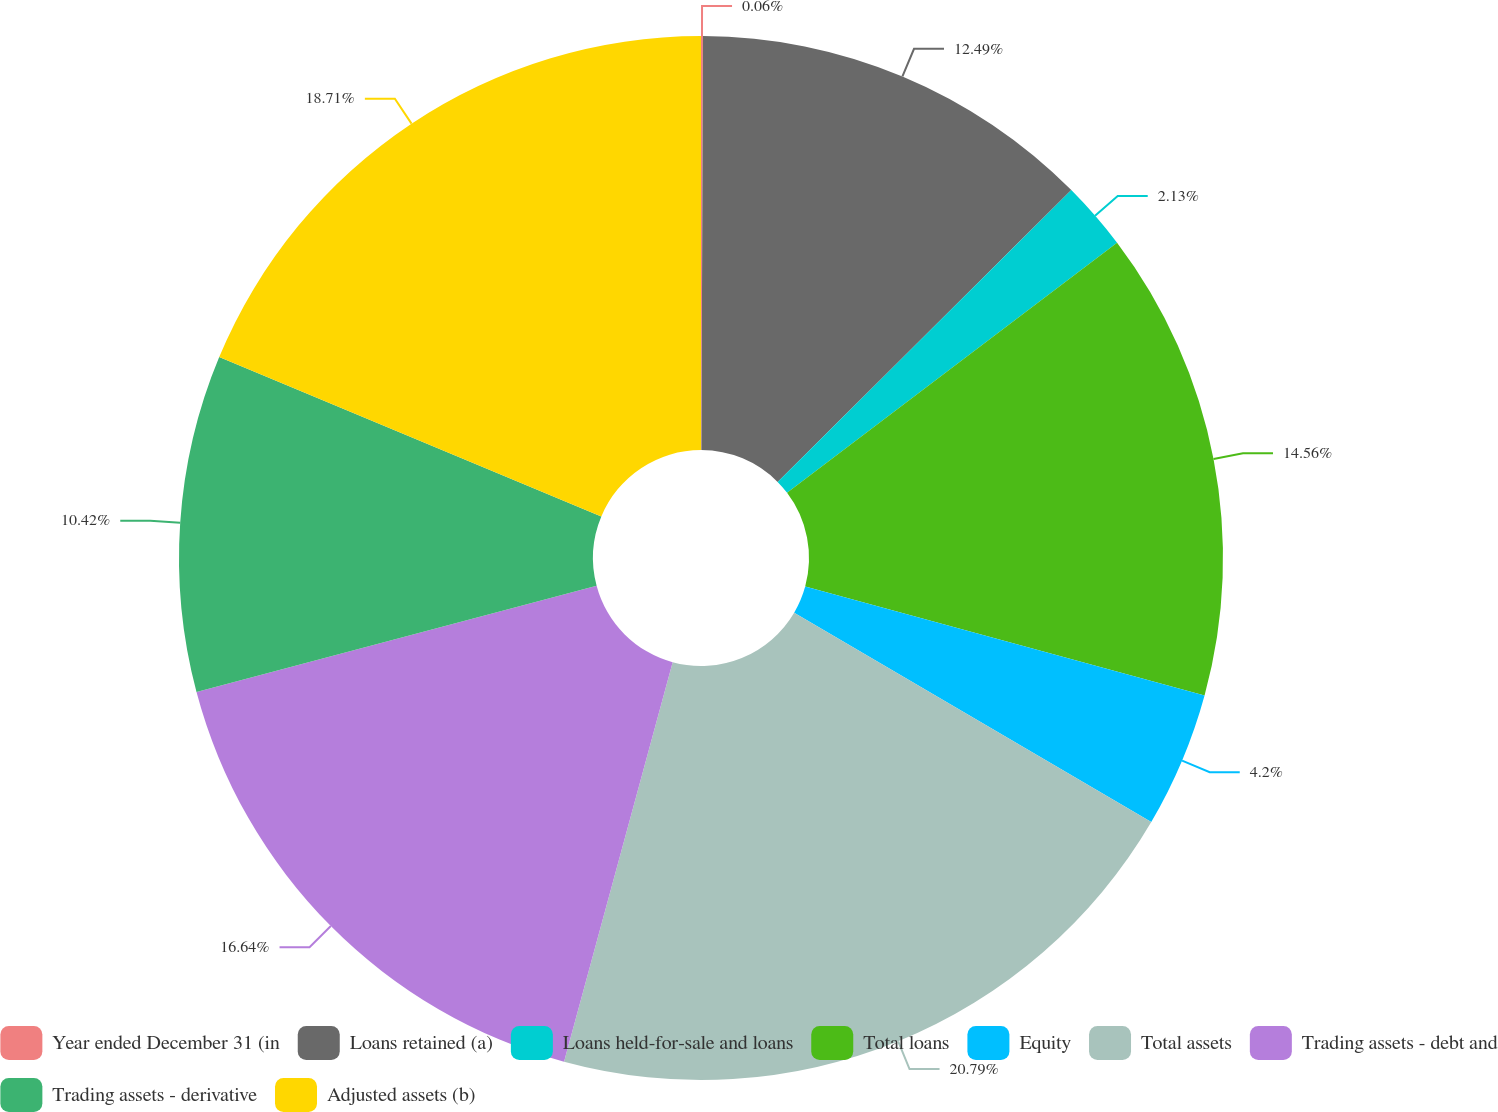<chart> <loc_0><loc_0><loc_500><loc_500><pie_chart><fcel>Year ended December 31 (in<fcel>Loans retained (a)<fcel>Loans held-for-sale and loans<fcel>Total loans<fcel>Equity<fcel>Total assets<fcel>Trading assets - debt and<fcel>Trading assets - derivative<fcel>Adjusted assets (b)<nl><fcel>0.06%<fcel>12.49%<fcel>2.13%<fcel>14.56%<fcel>4.2%<fcel>20.78%<fcel>16.64%<fcel>10.42%<fcel>18.71%<nl></chart> 